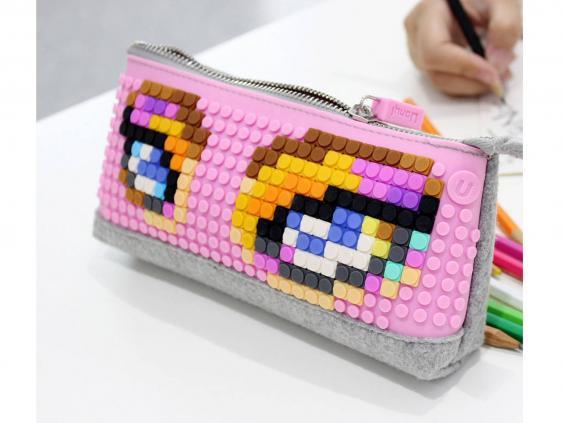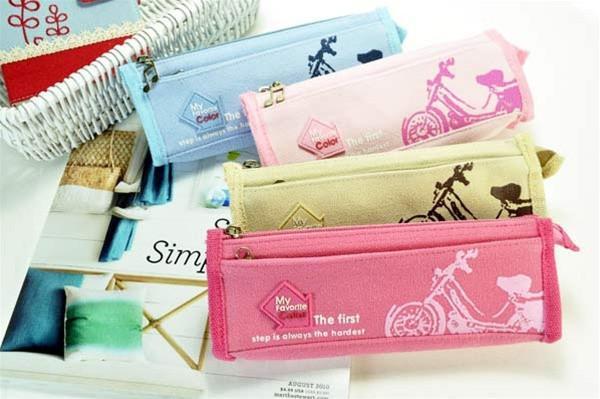The first image is the image on the left, the second image is the image on the right. Given the left and right images, does the statement "The left image shows exactly one pencil case." hold true? Answer yes or no. Yes. 